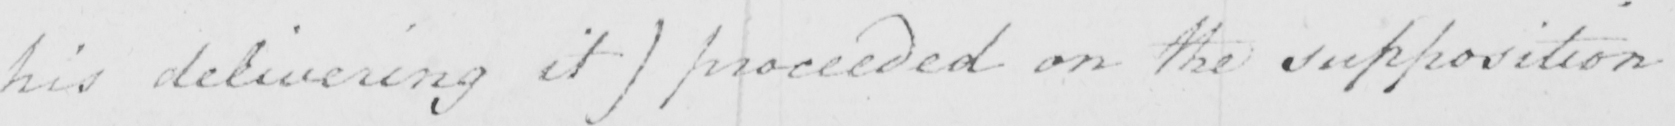Transcribe the text shown in this historical manuscript line. his delivering it )  proceeded on the supposition 